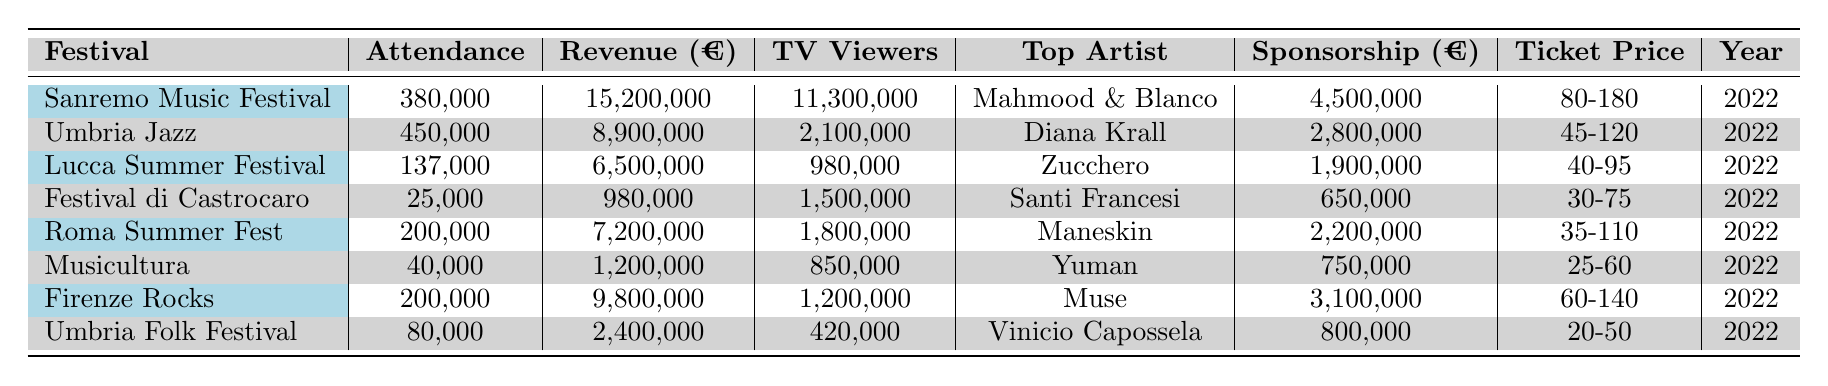What is the total attendance across all festivals listed? To find the total attendance, we add the attendance figures from each festival: 380000 + 450000 + 137000 + 25000 + 200000 + 40000 + 200000 + 80000 = 1370000.
Answer: 1370000 Which festival generated the highest revenue? By examining the revenue column, the Sanremo Music Festival shows the highest revenue at 15200000 euros.
Answer: Sanremo Music Festival How many festivals had an attendance of over 150,000? We review the attendance figures: Sanremo (380000), Umbria Jazz (450000), Lucca (137000), Roma (200000), and Firenze (200000). The festivals with attendance over 150,000 are 4 in total.
Answer: 4 What was the average ticket price range for the festivals? To find the average ticket price range, we calculate the average of the ranges: (80+180)/2 for Sanremo, (45+120)/2 for Umbria Jazz, (40+95)/2 for Lucca, (30+75)/2 for Castrocaro, (35+110)/2 for Roma, (25+60)/2 for Musicultura, (60+140)/2 for Firenze, and (20+50)/2 for Umbria Folk. Adding these averages and dividing by 8 gives us an approximate average ticket price of 73.75 euros.
Answer: 73.75 euros Did any festival have more than 10 million TV viewers? By inspecting the TV viewers column, only the Sanremo Music Festival has more than 10 million viewers, which confirms a 'yes' answer.
Answer: Yes Which festival had the top artist being "Maneskin"? Looking at the top artist column, we find that the Roma Summer Fest featured Maneskin as the top artist.
Answer: Roma Summer Fest What is the ratio of attendance to revenue for the "Lucca Summer Festival"? The attendance is 137,000 and the revenue is 6,500,000 euros. Therefore, the ratio is calculated as 137000/6500000 = 0.02108.
Answer: 0.02108 Which festival had the lowest sponsorship value? The Festival di Castrocaro has the lowest sponsorship value at 650000 euros, as seen in the sponsorship column.
Answer: Festival di Castrocaro If we combine the attendance of Umbria Jazz and Lucca Summer Festival, what is their total? The attendance figures for Umbria Jazz (450000) and Lucca Summer Festival (137000) sum up to 450000 + 137000 = 587000.
Answer: 587000 Which festival had the highest average number of TV viewers per attendee? To find this, we calculate TV viewers per attendee for each festival and compare: There would be various calculations leading to Umbria Jazz having the highest ratio of 4.67 views per attendee (2100000/450000).
Answer: Umbria Jazz How much did the festivals collectively earn from sponsorships? By adding up sponsorship values for all festivals: 4500000 + 2800000 + 1900000 + 650000 + 2200000 + 750000 + 3100000 + 800000 = 16650000 euros.
Answer: 16650000 euros 